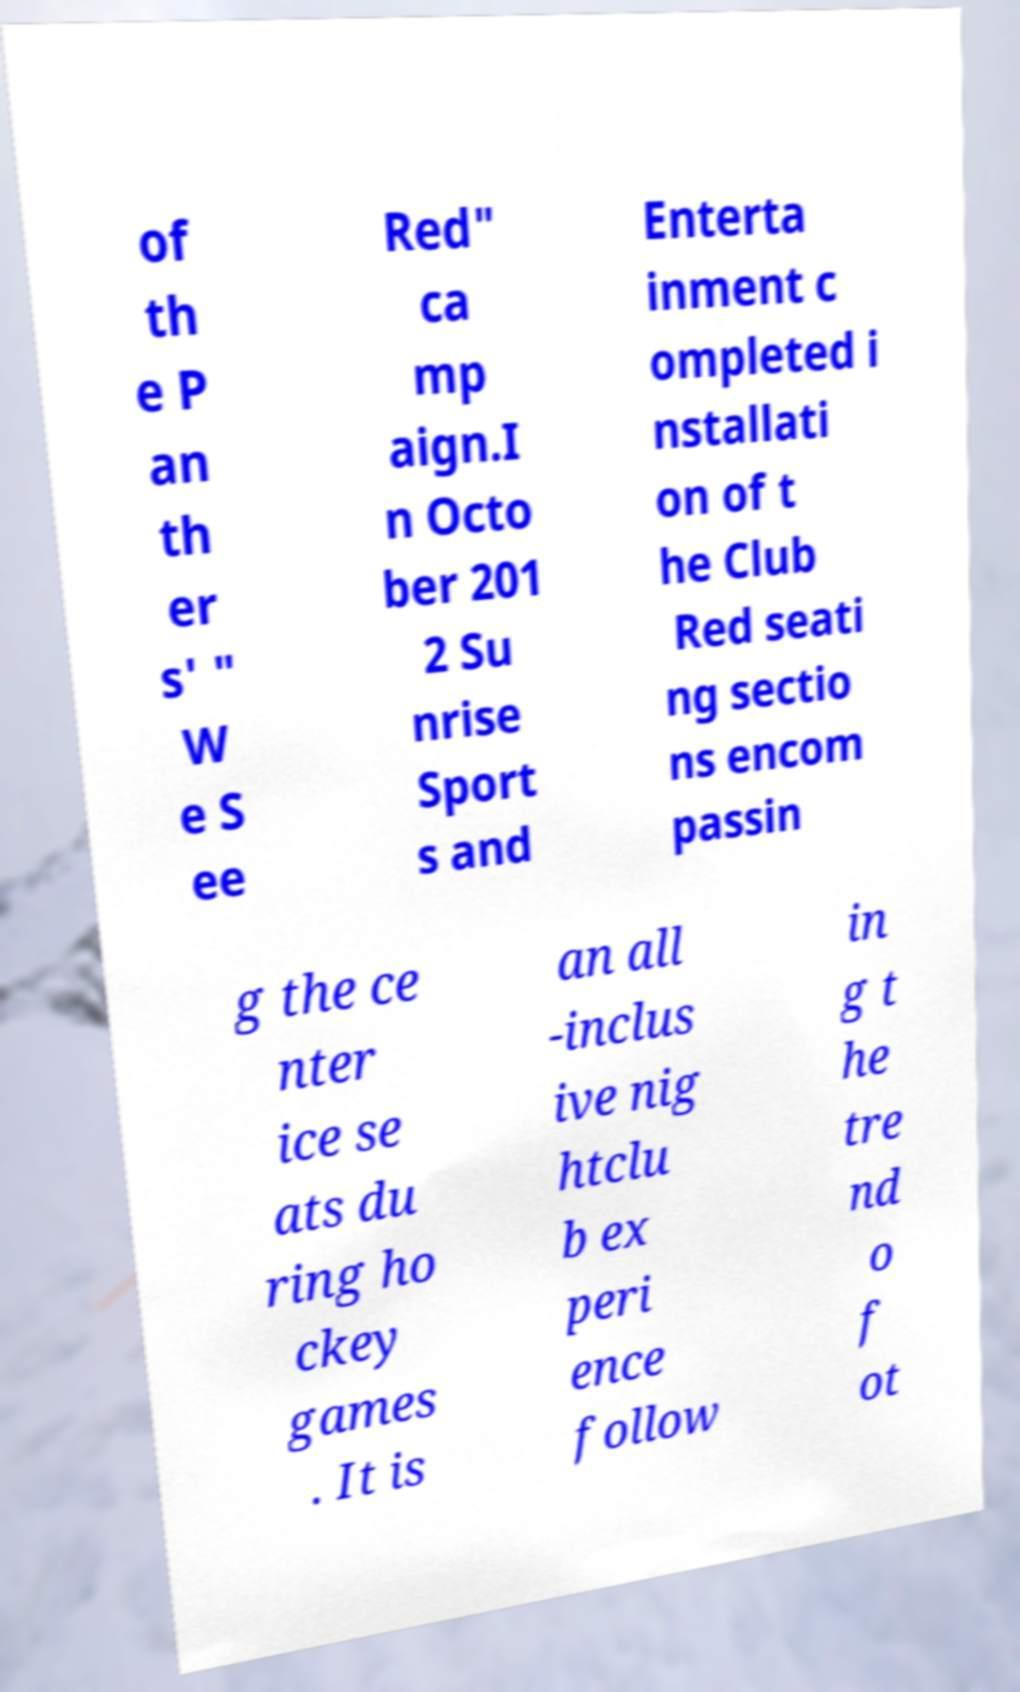Please read and relay the text visible in this image. What does it say? of th e P an th er s' " W e S ee Red" ca mp aign.I n Octo ber 201 2 Su nrise Sport s and Enterta inment c ompleted i nstallati on of t he Club Red seati ng sectio ns encom passin g the ce nter ice se ats du ring ho ckey games . It is an all -inclus ive nig htclu b ex peri ence follow in g t he tre nd o f ot 